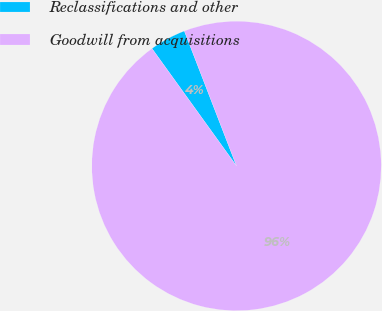Convert chart to OTSL. <chart><loc_0><loc_0><loc_500><loc_500><pie_chart><fcel>Reclassifications and other<fcel>Goodwill from acquisitions<nl><fcel>4.06%<fcel>95.94%<nl></chart> 